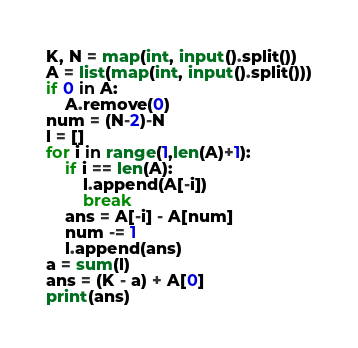Convert code to text. <code><loc_0><loc_0><loc_500><loc_500><_Python_>K, N = map(int, input().split())
A = list(map(int, input().split()))
if 0 in A:
    A.remove(0)
num = (N-2)-N
l = []
for i in range(1,len(A)+1):
    if i == len(A):
        l.append(A[-i])
        break
    ans = A[-i] - A[num]
    num -= 1
    l.append(ans)
a = sum(l)
ans = (K - a) + A[0]
print(ans)</code> 